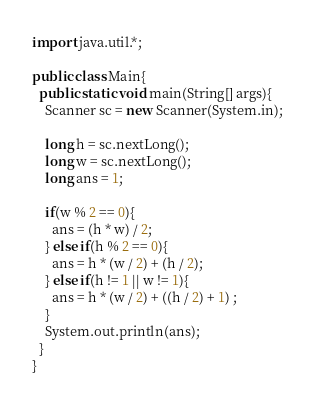<code> <loc_0><loc_0><loc_500><loc_500><_Java_>import java.util.*;

public class Main{
  public static void main(String[] args){
    Scanner sc = new Scanner(System.in);

    long h = sc.nextLong();
    long w = sc.nextLong();
    long ans = 1;

    if(w % 2 == 0){
      ans = (h * w) / 2;
    } else if(h % 2 == 0){
      ans = h * (w / 2) + (h / 2);
    } else if(h != 1 || w != 1){
      ans = h * (w / 2) + ((h / 2) + 1) ;
    }
    System.out.println(ans);
  }
}
</code> 